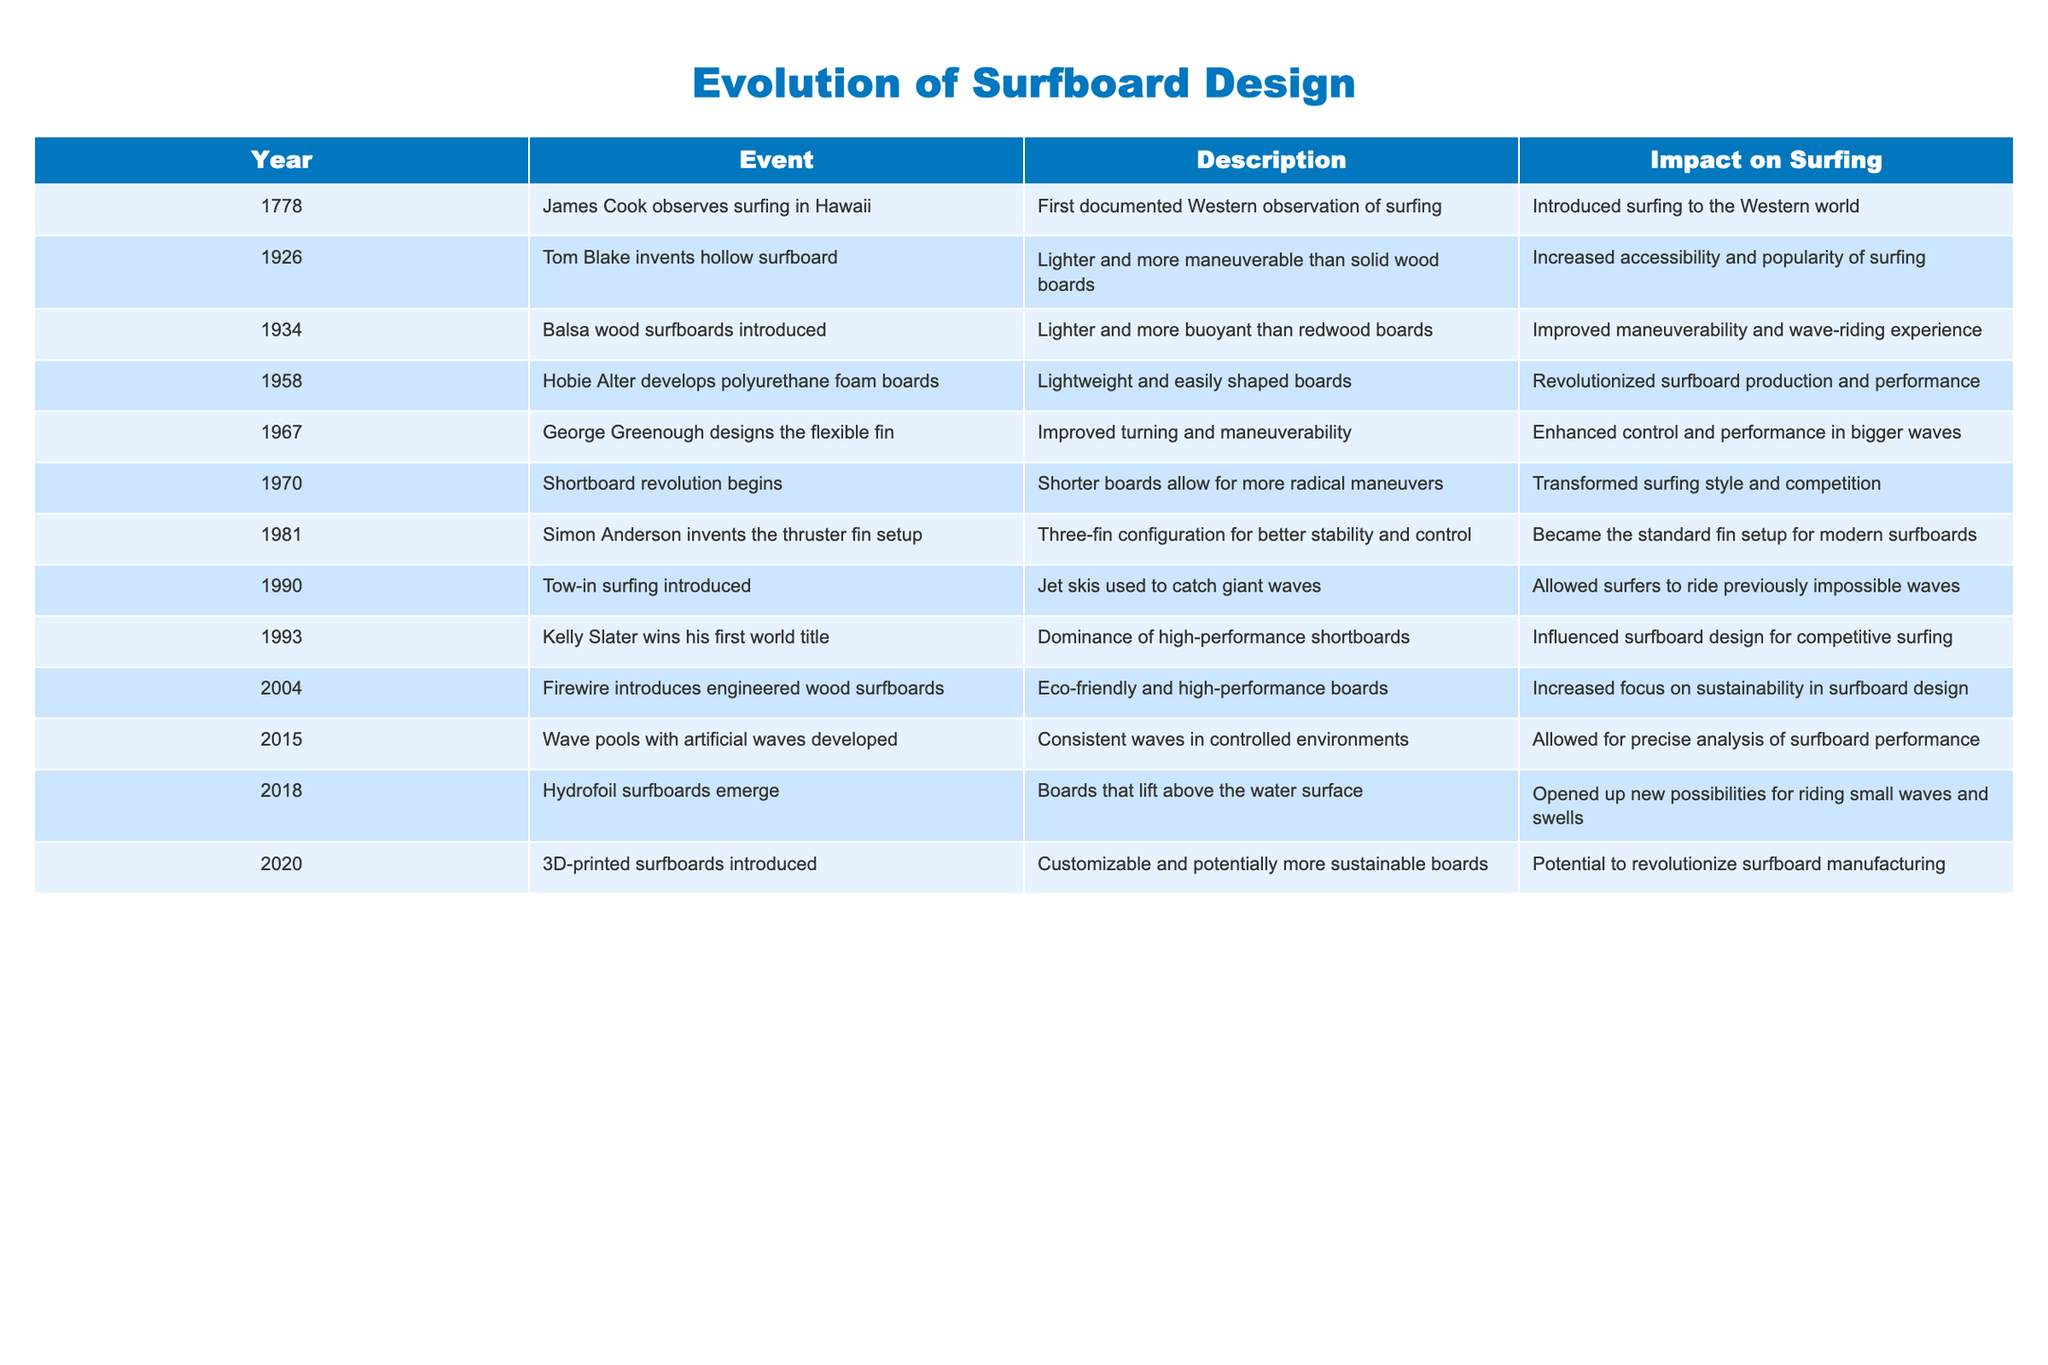What year did Tom Blake invent the hollow surfboard? The table states that Tom Blake invented the hollow surfboard in 1926. This can be found in the "Year" column beside his name in the "Event" column.
Answer: 1926 What was the impact of balsa wood surfboards introduced in 1934? According to the table, the introduction of balsa wood surfboards in 1934 improved maneuverability and the wave-riding experience. This is detailed in the "Impact on Surfing" column.
Answer: Improved maneuverability and wave-riding experience Which event had the earliest year listed in the table? The earliest event listed in the table is James Cook's observation of surfing in Hawaii, which occurred in 1778. This is the first row in the "Year" column.
Answer: 1778 What percentage of the events listed in the table involve significant changes to board materials or technology? There are 10 events listed. Events that involve significant changes to board materials or technology include: 1926 (hollow surfboard), 1934 (balsa wood), 1958 (polyurethane foam), 2004 (engineered wood), 2018 (hydrofoil surfboards), and 2020 (3D printed). That makes 6 out of 10 events. The percentage is (6/10)*100 = 60%.
Answer: 60% Did the introduction of tow-in surfing allow surfers to catch larger waves? Yes, the table indicates that tow-in surfing, introduced in 1990, allowed surfers to ride previously impossible waves. This is confirmed in the "Impact on Surfing" column.
Answer: Yes What was the main impact of Hobie Alter's polyurethane foam boards developed in 1958? The main impact was that they revolutionized surfboard production and performance, making boards lightweight and easily shaped. This is clearly noted under "Impact on Surfing" in the table.
Answer: Revolutionized surfboard production and performance What was the last event listed in the timeline and its impact on surfing? The last event is the introduction of 3D-printed surfboards in 2020. The impact is that they are customizable and potentially more sustainable, as stated in the "Impact on Surfing" column.
Answer: Customizable and potentially more sustainable boards How much time elapsed between the introduction of the thruster fin setup and Kelly Slater winning his first world title? The thruster fin setup was invented in 1981, and Kelly Slater won his first world title in 1993. The time elapsed is 1993 - 1981 = 12 years.
Answer: 12 years What prompted the introduction of engineered wood surfboards in 2004? The table indicates that engineered wood surfboards were introduced with a focus on sustainability, as noted in the "Impact on Surfing" column of the table.
Answer: Focus on sustainability 